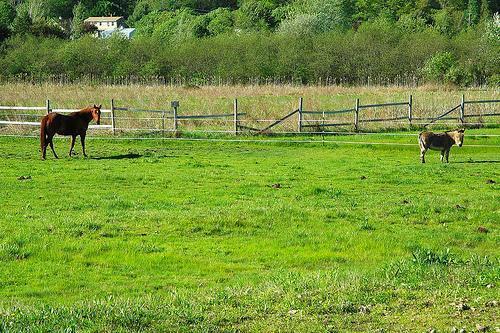How many donkeys are there?
Give a very brief answer. 1. 